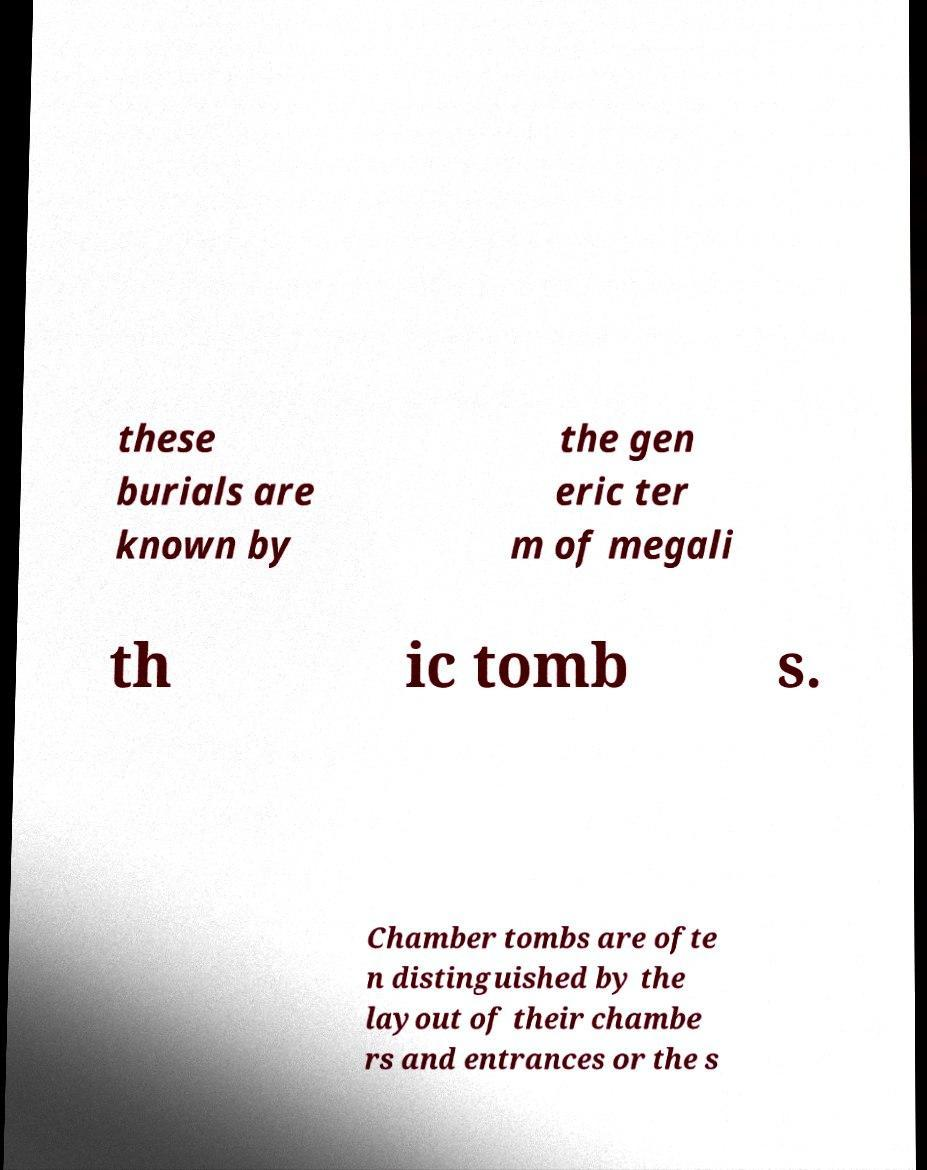Can you accurately transcribe the text from the provided image for me? these burials are known by the gen eric ter m of megali th ic tomb s. Chamber tombs are ofte n distinguished by the layout of their chambe rs and entrances or the s 